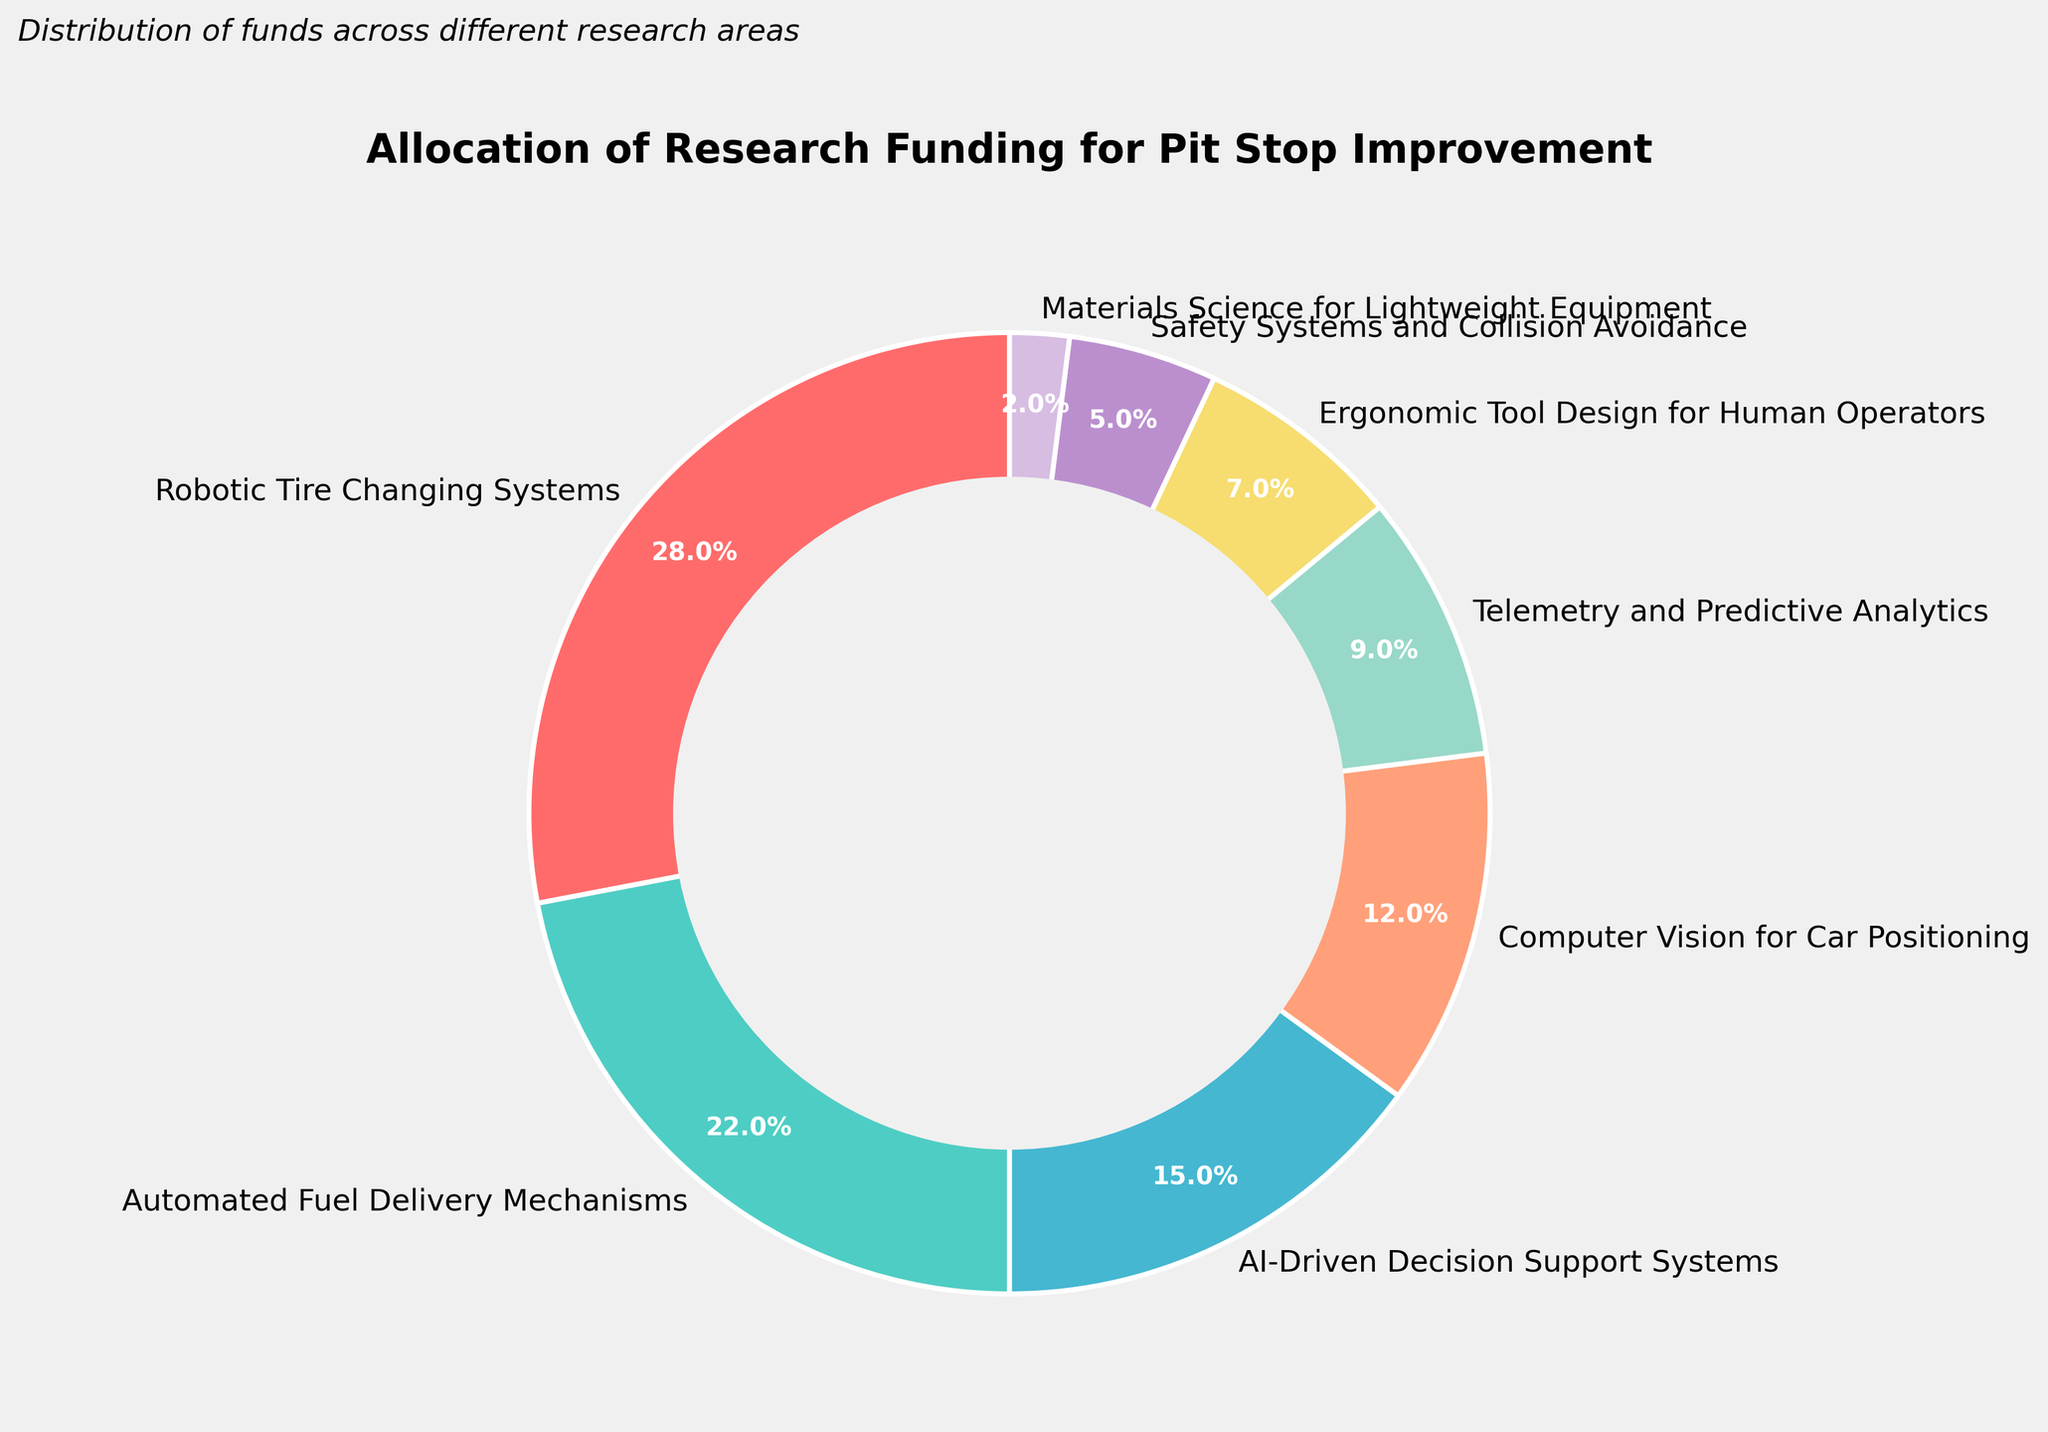What is the largest funding allocation for a single research area? According to the pie chart, the largest funding allocation is represented by the section of the pie chart labeled "Robotic Tire Changing Systems." The percentage shown is 28%.
Answer: 28% What is the total funding allocation for areas focusing on automation (Robotic Tire Changing Systems, Automated Fuel Delivery Mechanisms, AI-Driven Decision Support Systems)? The funding allocations for the areas focusing on automation are 28% for Robotic Tire Changing Systems, 22% for Automated Fuel Delivery Mechanisms, and 15% for AI-Driven Decision Support Systems. Adding these together, the total is 28% + 22% + 15% = 65%.
Answer: 65% Which research area has the smallest funding allocation? Looking at the smallest sections of the pie chart, the research area labeled "Materials Science for Lightweight Equipment" has the smallest percentage, which is 2%.
Answer: Materials Science for Lightweight Equipment Between "Computer Vision for Car Positioning" and "Telemetry and Predictive Analytics," which research area received more funding? According to the chart, "Computer Vision for Car Positioning" received 12% and "Telemetry and Predictive Analytics" received 9%. Since 12% is greater than 9%, "Computer Vision for Car Positioning" received more funding.
Answer: Computer Vision for Car Positioning What is the combined funding allocation for "Safety Systems and Collision Avoidance" and "Ergonomic Tool Design for Human Operators"? The funding allocations are 5% for Safety Systems and Collision Avoidance and 7% for Ergonomic Tool Design for Human Operators. Adding these together, the combined allocation is 5% + 7% = 12%.
Answer: 12% Which research area is represented by the purple section of the pie chart? The purple section of the pie chart corresponds to the segment labeled "Materials Science for Lightweight Equipment."
Answer: Materials Science for Lightweight Equipment What percentage of the total funding is allocated to both "AI-Driven Decision Support Systems" and "Robotic Tire Changing Systems"? The allocations for "AI-Driven Decision Support Systems" and "Robotic Tire Changing Systems" are 15% and 28%, respectively. Adding these together, the total allocation is 15% + 28% = 43%.
Answer: 43% List the three research areas with the highest funding allocation in descending order. The three research areas with the highest funding are "Robotic Tire Changing Systems" with 28%, "Automated Fuel Delivery Mechanisms" with 22%, and "AI-Driven Decision Support Systems" with 15%.
Answer: Robotic Tire Changing Systems, Automated Fuel Delivery Mechanisms, AI-Driven Decision Support Systems How much more funding does "Robotic Tire Changing Systems" receive compared to "Computer Vision for Car Positioning"? "Robotic Tire Changing Systems" receives 28% and "Computer Vision for Car Positioning" receives 12%. The difference in funding allocation is 28% - 12% = 16%.
Answer: 16% What is the average funding allocation for all research areas? To find the average, sum the funding allocations: 28% + 22% + 15% + 12% + 9% + 7% + 5% + 2% = 100%. Since there are 8 research areas, divide the total by 8: 100% / 8 = 12.5%.
Answer: 12.5% 